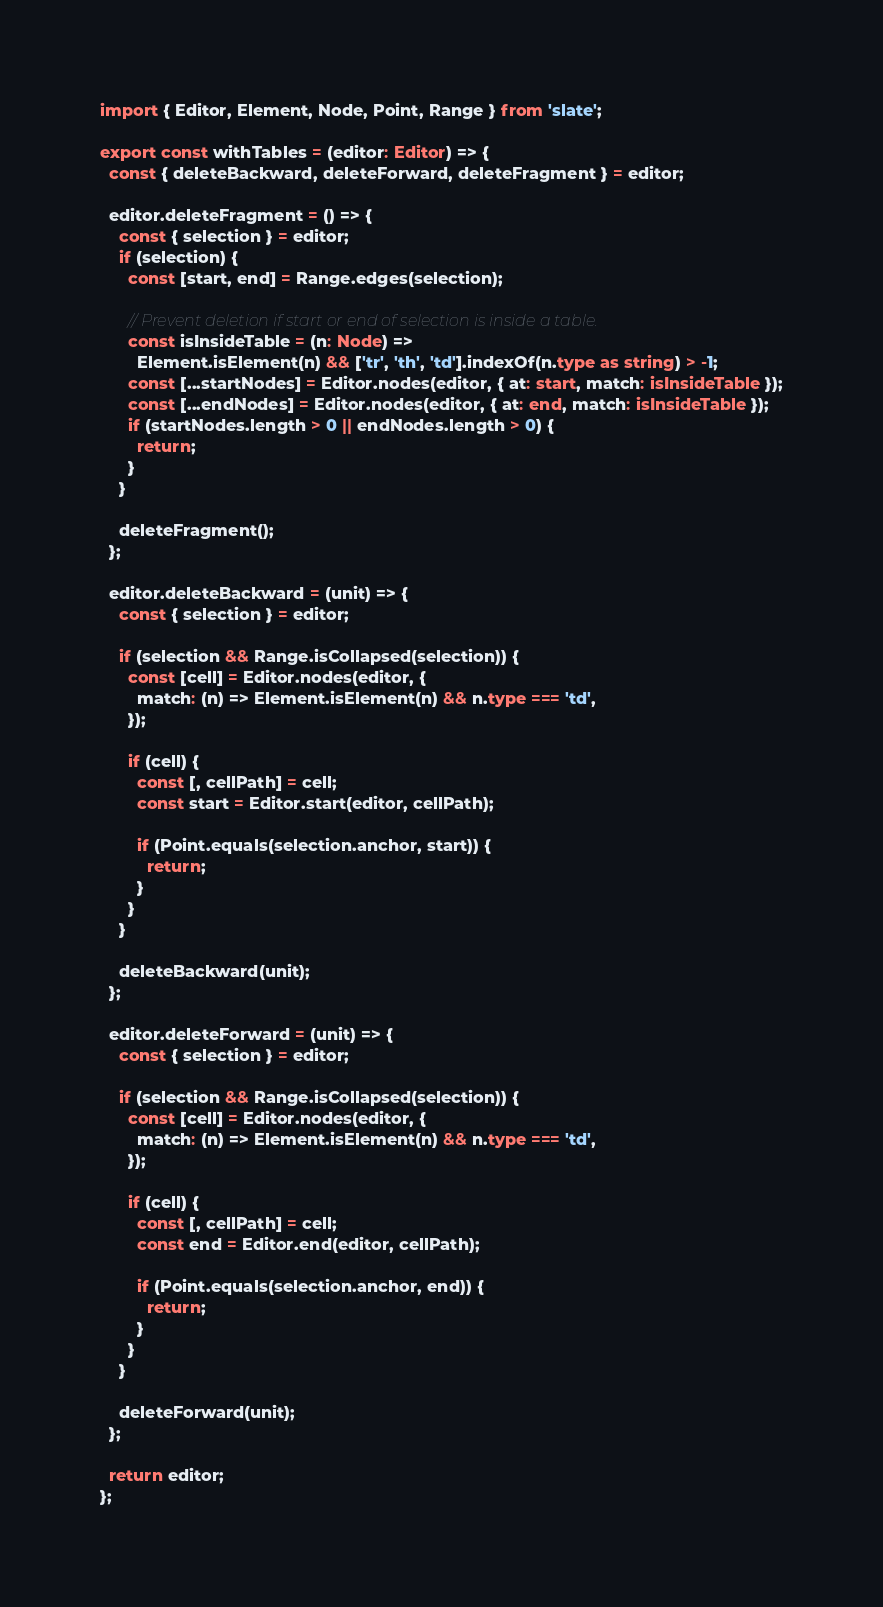<code> <loc_0><loc_0><loc_500><loc_500><_TypeScript_>import { Editor, Element, Node, Point, Range } from 'slate';

export const withTables = (editor: Editor) => {
  const { deleteBackward, deleteForward, deleteFragment } = editor;

  editor.deleteFragment = () => {
    const { selection } = editor;
    if (selection) {
      const [start, end] = Range.edges(selection);

      // Prevent deletion if start or end of selection is inside a table.
      const isInsideTable = (n: Node) =>
        Element.isElement(n) && ['tr', 'th', 'td'].indexOf(n.type as string) > -1;
      const [...startNodes] = Editor.nodes(editor, { at: start, match: isInsideTable });
      const [...endNodes] = Editor.nodes(editor, { at: end, match: isInsideTable });
      if (startNodes.length > 0 || endNodes.length > 0) {
        return;
      }
    }

    deleteFragment();
  };

  editor.deleteBackward = (unit) => {
    const { selection } = editor;

    if (selection && Range.isCollapsed(selection)) {
      const [cell] = Editor.nodes(editor, {
        match: (n) => Element.isElement(n) && n.type === 'td',
      });

      if (cell) {
        const [, cellPath] = cell;
        const start = Editor.start(editor, cellPath);

        if (Point.equals(selection.anchor, start)) {
          return;
        }
      }
    }

    deleteBackward(unit);
  };

  editor.deleteForward = (unit) => {
    const { selection } = editor;

    if (selection && Range.isCollapsed(selection)) {
      const [cell] = Editor.nodes(editor, {
        match: (n) => Element.isElement(n) && n.type === 'td',
      });

      if (cell) {
        const [, cellPath] = cell;
        const end = Editor.end(editor, cellPath);

        if (Point.equals(selection.anchor, end)) {
          return;
        }
      }
    }

    deleteForward(unit);
  };

  return editor;
};
</code> 